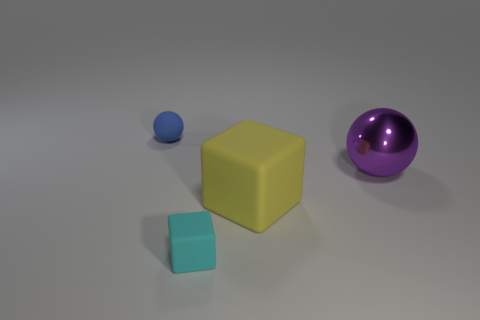There is a sphere that is to the left of the big shiny object; what size is it?
Your answer should be compact. Small. Do the blue ball and the yellow object have the same size?
Your response must be concise. No. Is the number of large yellow things behind the big shiny ball less than the number of tiny cyan matte objects that are right of the tiny matte sphere?
Offer a very short reply. Yes. There is a thing that is left of the large cube and behind the cyan rubber object; what size is it?
Provide a short and direct response. Small. Are there any large yellow things right of the sphere on the right side of the rubber thing that is behind the large ball?
Provide a succinct answer. No. Is there a yellow rubber object?
Provide a succinct answer. Yes. Are there more blue objects behind the large purple object than yellow matte things that are on the left side of the tiny cyan matte cube?
Provide a short and direct response. Yes. There is a yellow block that is made of the same material as the tiny blue object; what is its size?
Your answer should be very brief. Large. There is a thing behind the sphere that is on the right side of the object that is behind the big purple metallic ball; what size is it?
Your answer should be very brief. Small. There is a matte block that is in front of the big cube; what is its color?
Offer a terse response. Cyan. 